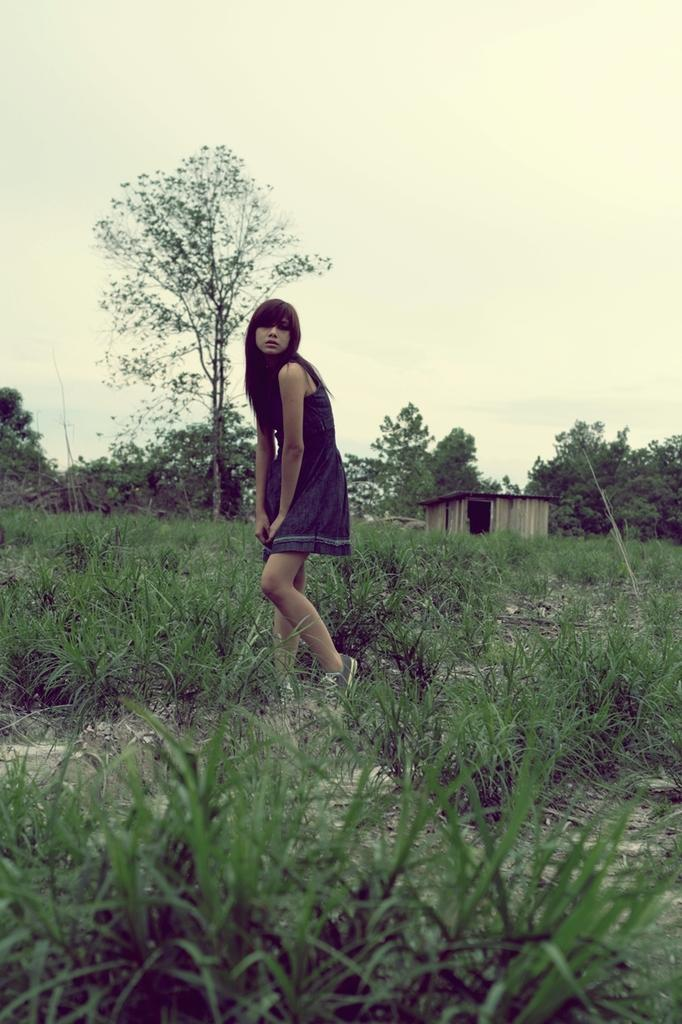Who is present in the image? There is a woman in the image. Where is the woman located? The woman is on the grass. What can be seen in the background of the image? There is a shed, trees, and the sky visible in the background of the image. What time of day does the image appear to be taken? The image appears to be taken during the day. What is the year of the vein visible on the slope in the image? There is no vein or slope present in the image; it features a woman on the grass with a background of a shed, trees, and the sky. 